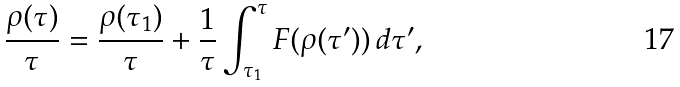Convert formula to latex. <formula><loc_0><loc_0><loc_500><loc_500>\frac { \rho ( \tau ) } { \tau } = \frac { \rho ( \tau _ { 1 } ) } { \tau } + \frac { 1 } { \tau } \int _ { \tau _ { 1 } } ^ { \tau } F ( \rho ( \tau ^ { \prime } ) ) \, d \tau ^ { \prime } ,</formula> 